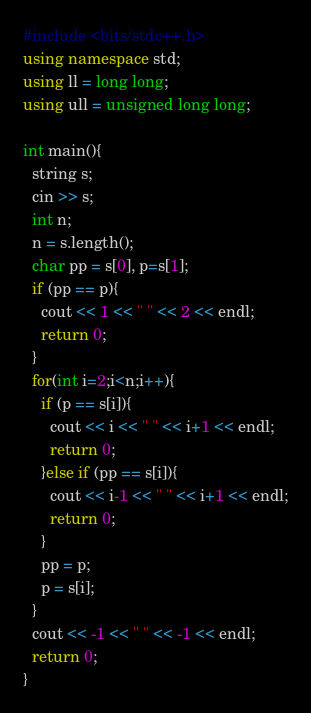Convert code to text. <code><loc_0><loc_0><loc_500><loc_500><_C++_>#include <bits/stdc++.h>
using namespace std;
using ll = long long;
using ull = unsigned long long;

int main(){
  string s;
  cin >> s;
  int n;
  n = s.length();
  char pp = s[0], p=s[1];
  if (pp == p){
    cout << 1 << " " << 2 << endl;
    return 0;
  }
  for(int i=2;i<n;i++){
    if (p == s[i]){
      cout << i << " " << i+1 << endl;
      return 0;
    }else if (pp == s[i]){
      cout << i-1 << " " << i+1 << endl;
      return 0;
    }
    pp = p;
    p = s[i];
  }
  cout << -1 << " " << -1 << endl;
  return 0;
}</code> 